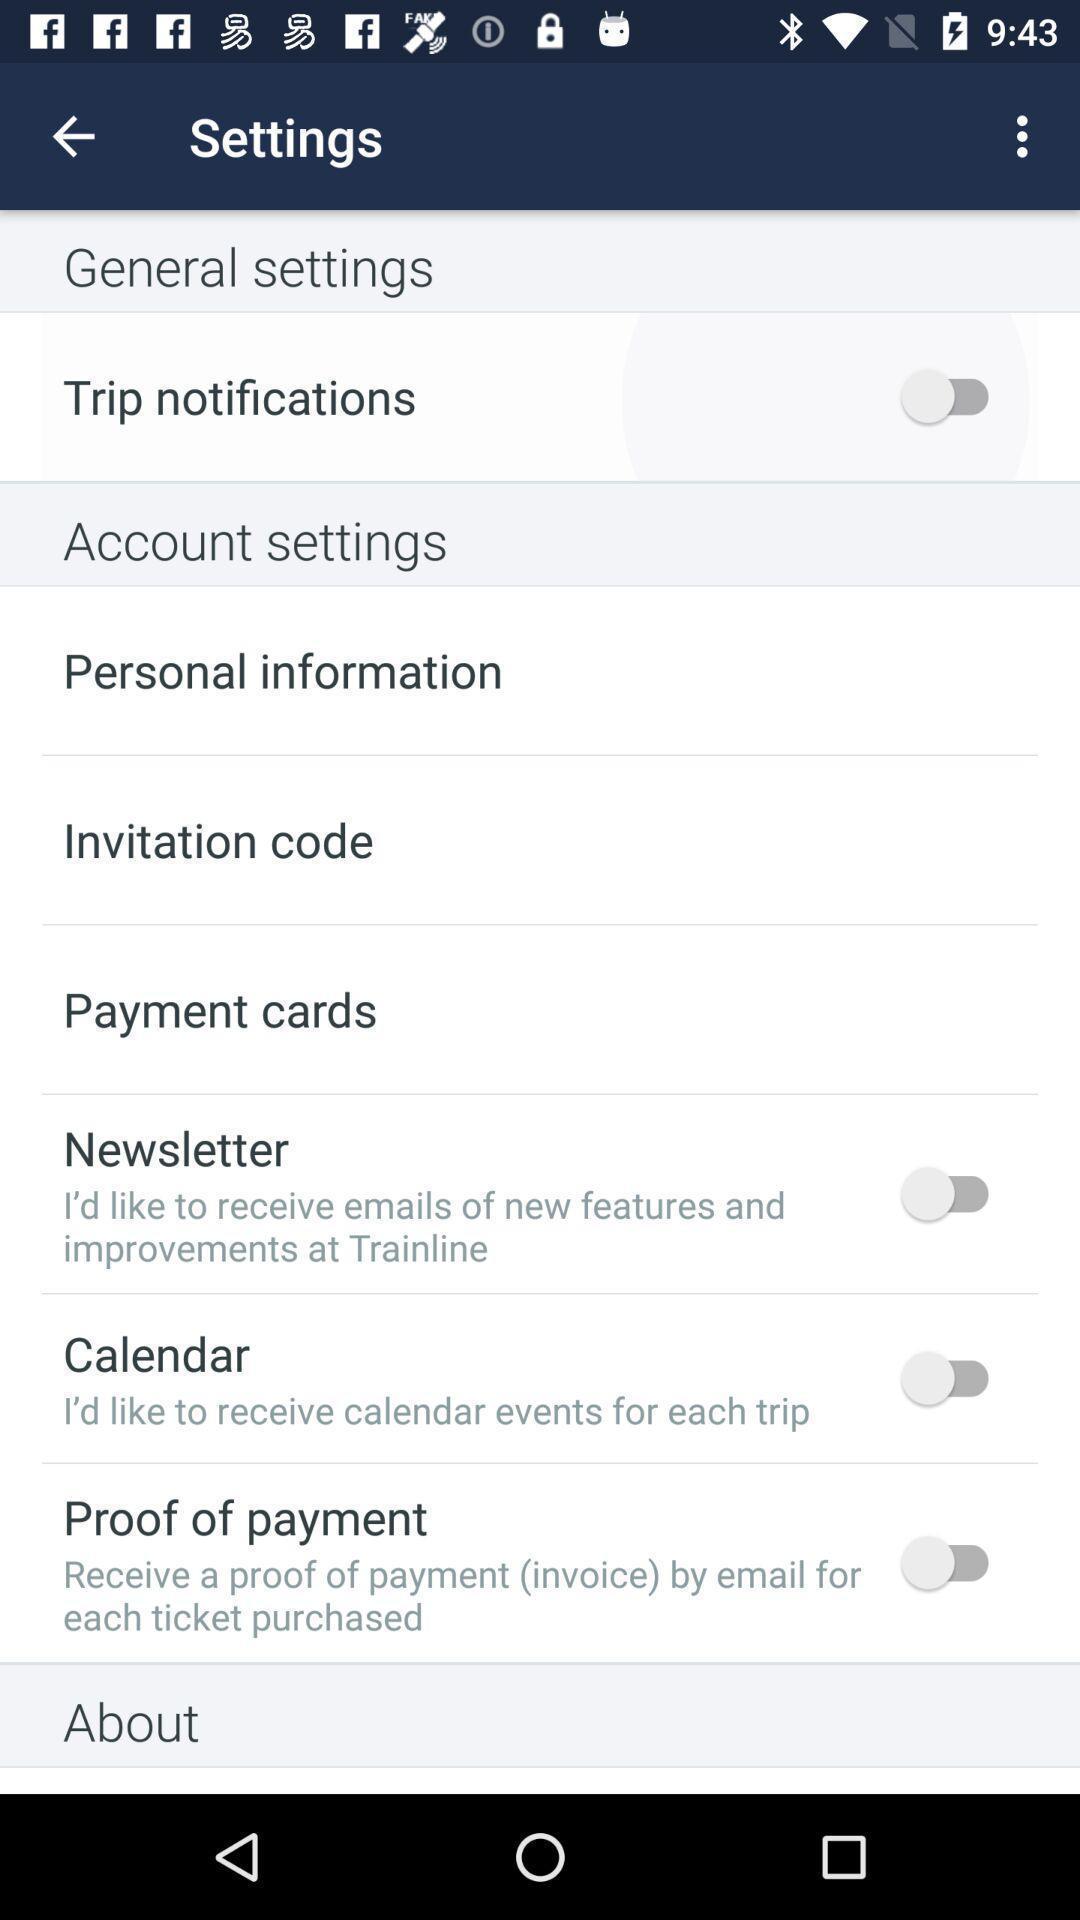Give me a narrative description of this picture. Screen displaying multiple setting options in a travelling application. 